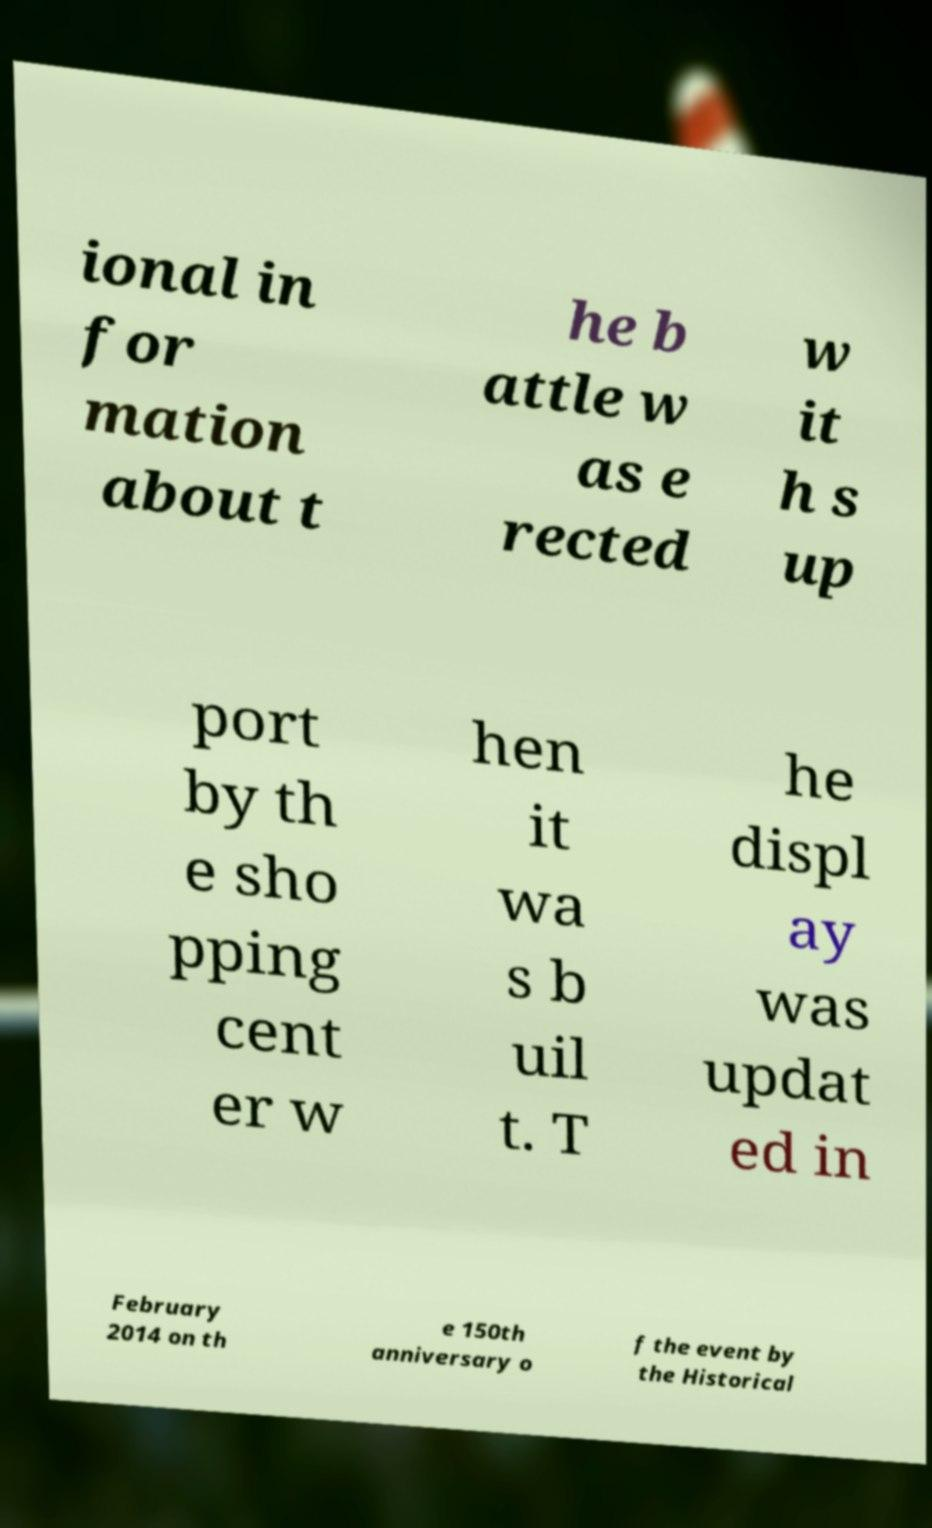I need the written content from this picture converted into text. Can you do that? ional in for mation about t he b attle w as e rected w it h s up port by th e sho pping cent er w hen it wa s b uil t. T he displ ay was updat ed in February 2014 on th e 150th anniversary o f the event by the Historical 